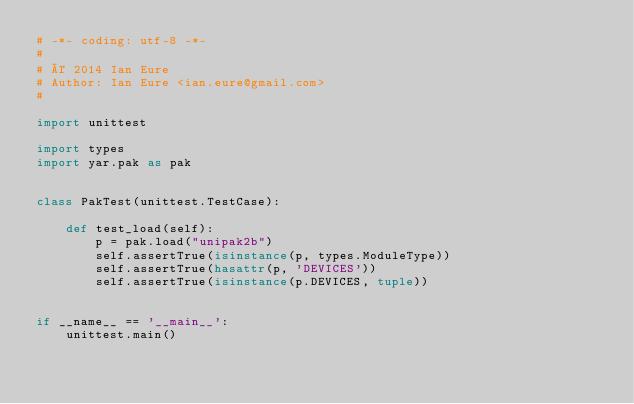Convert code to text. <code><loc_0><loc_0><loc_500><loc_500><_Python_># -*- coding: utf-8 -*-
#
# © 2014 Ian Eure
# Author: Ian Eure <ian.eure@gmail.com>
#

import unittest

import types
import yar.pak as pak


class PakTest(unittest.TestCase):

    def test_load(self):
        p = pak.load("unipak2b")
        self.assertTrue(isinstance(p, types.ModuleType))
        self.assertTrue(hasattr(p, 'DEVICES'))
        self.assertTrue(isinstance(p.DEVICES, tuple))


if __name__ == '__main__':
    unittest.main()
</code> 